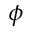<formula> <loc_0><loc_0><loc_500><loc_500>\phi</formula> 